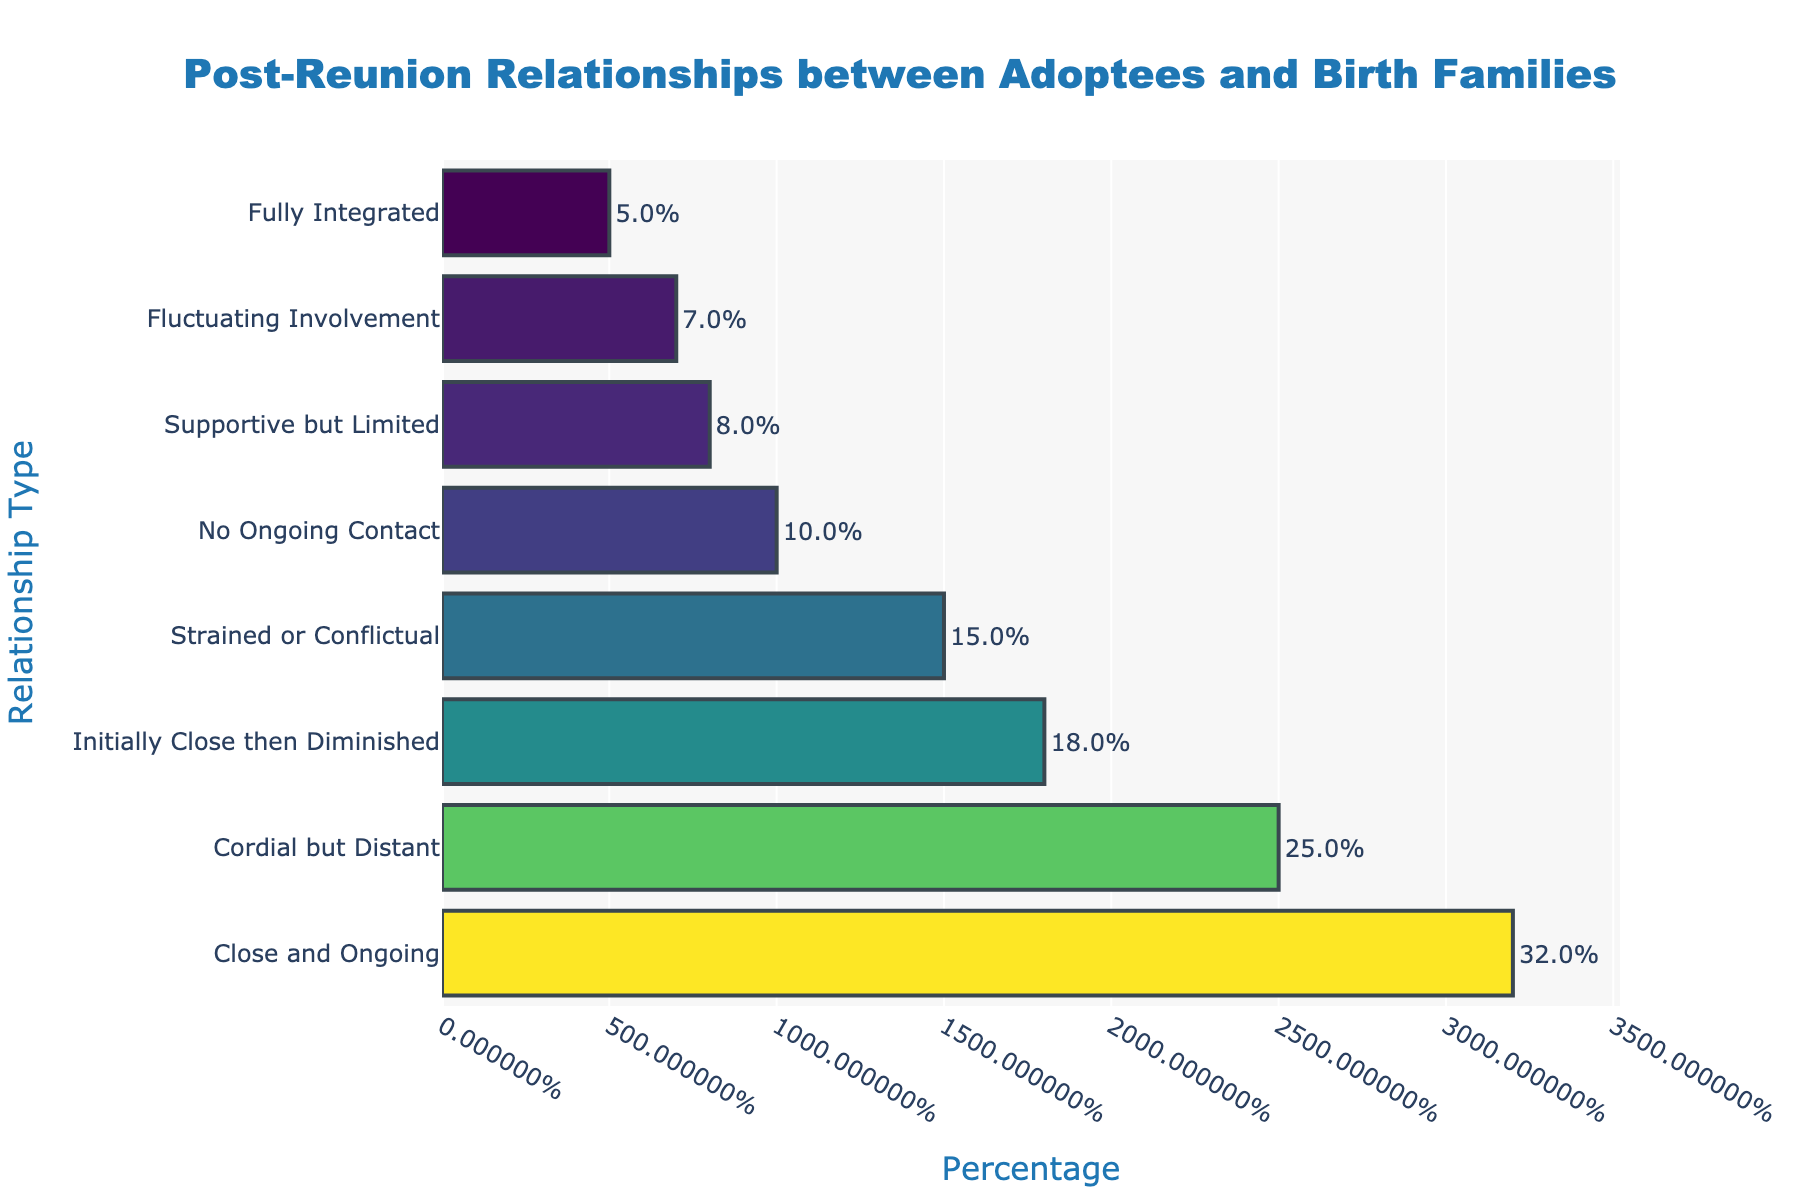What's the most common type of post-reunion relationship? The figure shows the percentage distribution of various post-reunion relationship types. The bar representing 'Close and Ongoing' is the longest and has the highest percentage.
Answer: Close and Ongoing Which relationship type has the smallest percentage? By observing the figure, the bar for 'Fully Integrated' is the shortest, indicating it has the smallest percentage.
Answer: Fully Integrated How much greater is the percentage of 'Cordial but Distant' compared to 'Strained or Conflictual'? The percentage for 'Cordial but Distant' is 25%, and for 'Strained or Conflictual' is 15%. Subtracting 15 from 25 gives the difference.
Answer: 10% What is the combined percentage of 'Fluctuating Involvement' and 'Supportive but Limited'? Adding the percentages for 'Fluctuating Involvement' (7%) and 'Supportive but Limited' (8%) gives the combined total.
Answer: 15% Are there more adoptees who have 'Close and Ongoing' relationships than those who have 'No Ongoing Contact'? The figure shows that 'Close and Ongoing' has a percentage of 32% while 'No Ongoing Contact' has 10%. Since 32% is greater than 10%, there are more adoptees in 'Close and Ongoing' relationships.
Answer: Yes What proportion of adoptees have some form of ongoing contact (either 'Close and Ongoing', 'Cordial but Distant', or 'Initially Close then Diminished')? Adding up the percentages for 'Close and Ongoing' (32%), 'Cordial but Distant' (25%), and 'Initially Close then Diminished' (18%) gives the total proportion.
Answer: 75% Which relationship types have a percentage between 10% and 20%? Referring to the figure, the bars for 'Initially Close then Diminished' (18%) and 'Strained or Conflictual' (15%) fall within the 10% to 20% range.
Answer: Initially Close then Diminished, Strained or Conflictual Is the percentage of 'Strained or Conflictual' relationships higher than 'No Ongoing Contact'? The figure shows 'Strained or Conflictual' at 15% and 'No Ongoing Contact' at 10%. Since 15% is greater than 10%, 'Strained or Conflictual' is higher.
Answer: Yes 